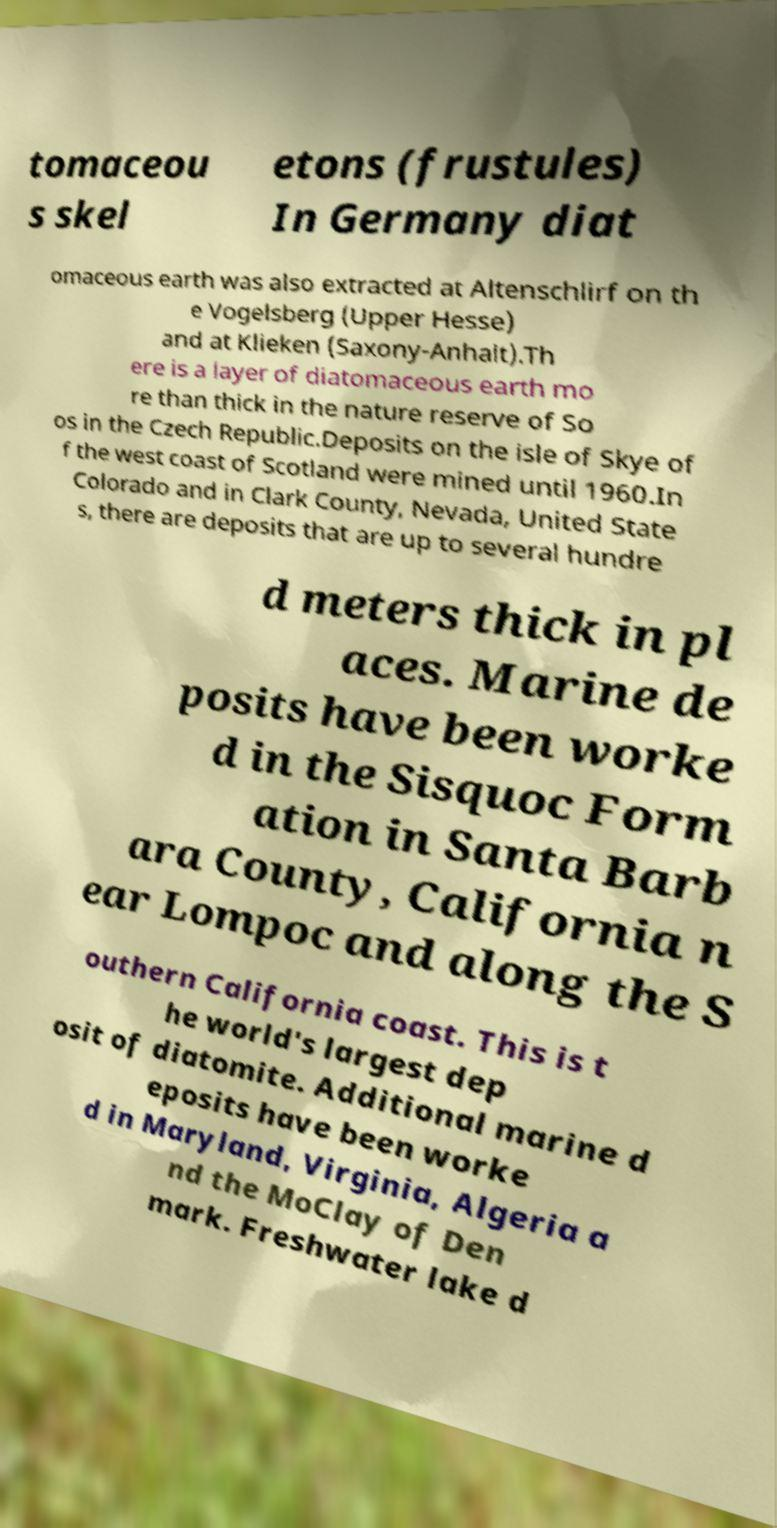Could you extract and type out the text from this image? tomaceou s skel etons (frustules) In Germany diat omaceous earth was also extracted at Altenschlirf on th e Vogelsberg (Upper Hesse) and at Klieken (Saxony-Anhalt).Th ere is a layer of diatomaceous earth mo re than thick in the nature reserve of So os in the Czech Republic.Deposits on the isle of Skye of f the west coast of Scotland were mined until 1960.In Colorado and in Clark County, Nevada, United State s, there are deposits that are up to several hundre d meters thick in pl aces. Marine de posits have been worke d in the Sisquoc Form ation in Santa Barb ara County, California n ear Lompoc and along the S outhern California coast. This is t he world's largest dep osit of diatomite. Additional marine d eposits have been worke d in Maryland, Virginia, Algeria a nd the MoClay of Den mark. Freshwater lake d 